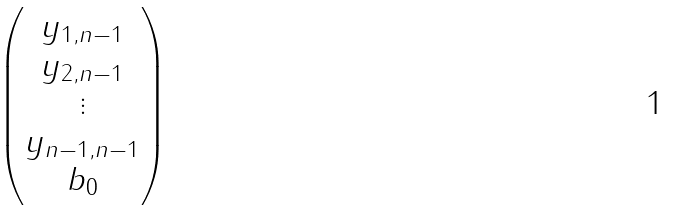Convert formula to latex. <formula><loc_0><loc_0><loc_500><loc_500>\begin{pmatrix} y _ { 1 , n - 1 } \\ y _ { 2 , n - 1 } \\ \vdots \\ y _ { n - 1 , n - 1 } \\ b _ { 0 } \end{pmatrix}</formula> 